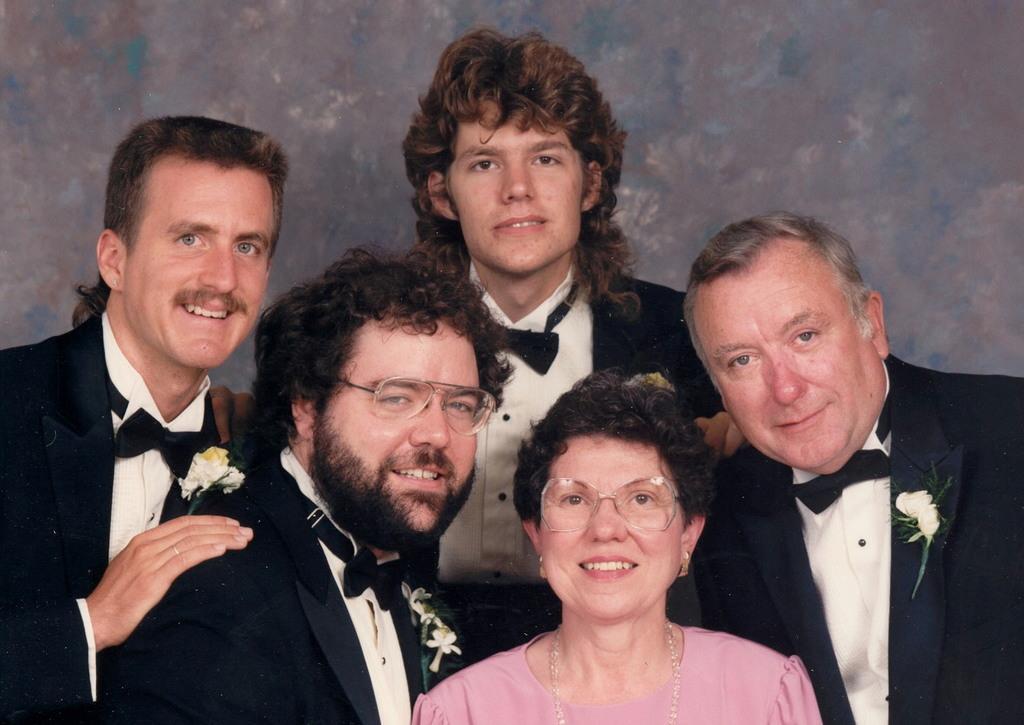In one or two sentences, can you explain what this image depicts? This picture contains five people. Out of them, four are men and the one is a woman. All of them are smiling. The woman in pink dress is wearing spectacles. Behind them, it is grey in color. All of them are posing for the photo. 